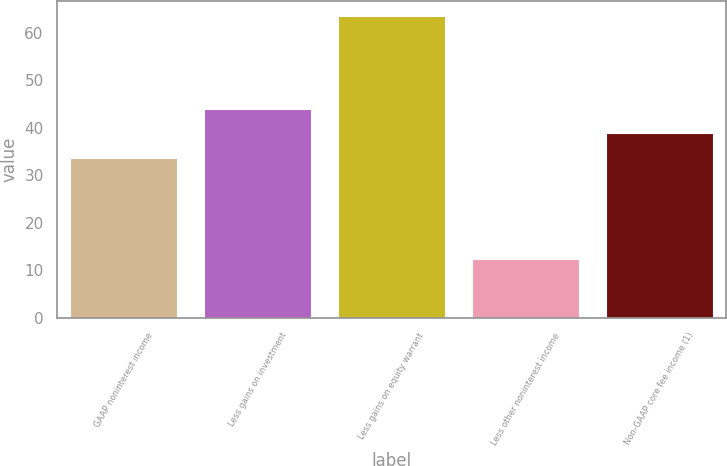Convert chart. <chart><loc_0><loc_0><loc_500><loc_500><bar_chart><fcel>GAAP noninterest income<fcel>Less gains on investment<fcel>Less gains on equity warrant<fcel>Less other noninterest income<fcel>Non-GAAP core fee income (1)<nl><fcel>33.7<fcel>43.92<fcel>63.4<fcel>12.3<fcel>38.81<nl></chart> 